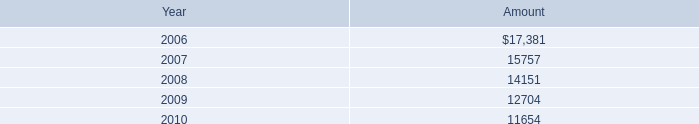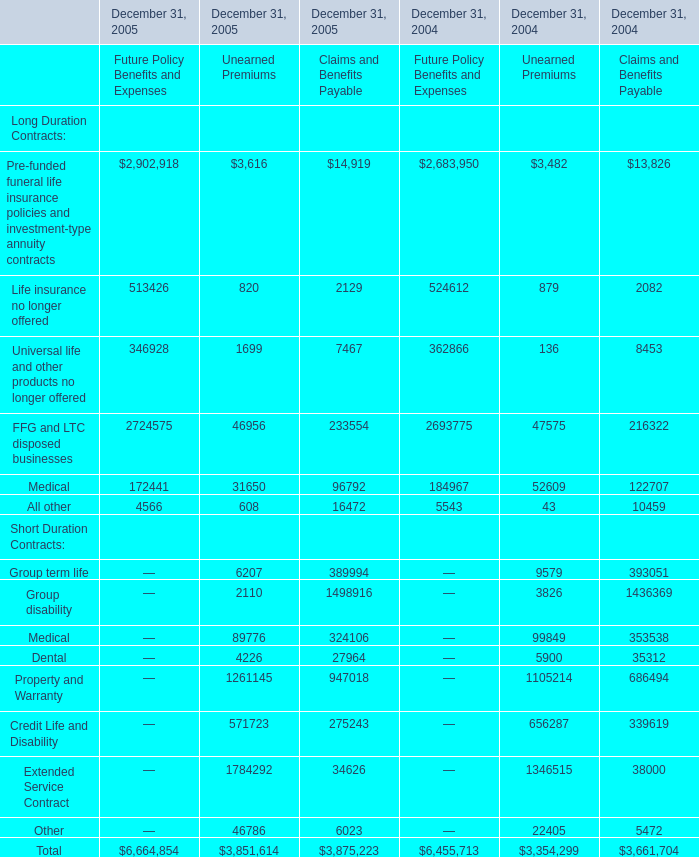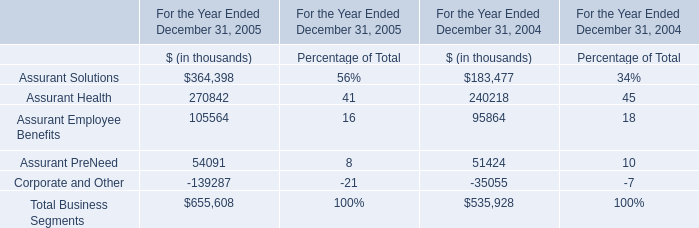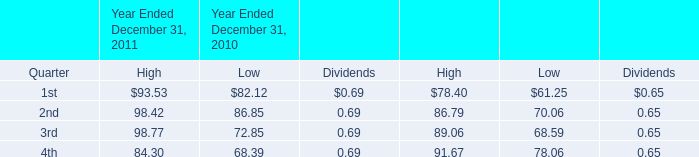What is the growing rate of Unearned Premiums for Extended Service Contract on December 31 in the year where the Unearned Premiums for Total on December 31 is the most? 
Computations: ((1784292 - 1346515) / 1346515)
Answer: 0.32512. 